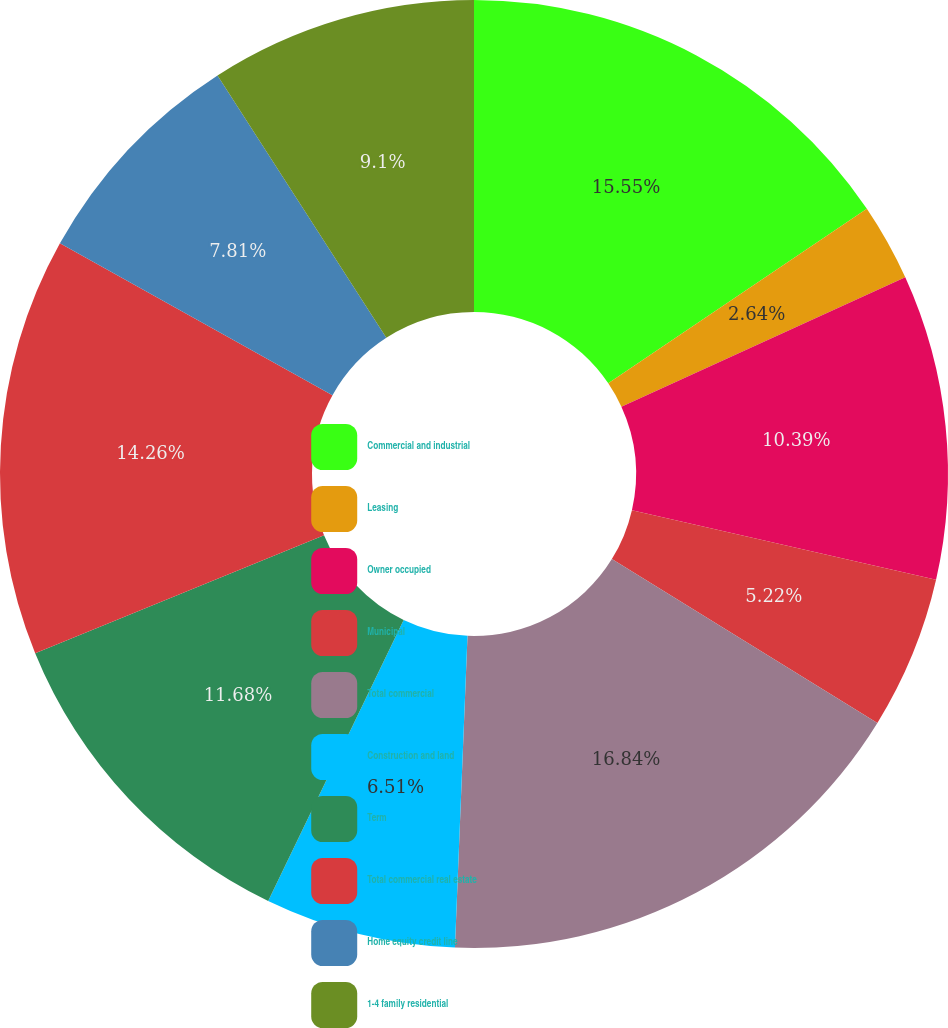<chart> <loc_0><loc_0><loc_500><loc_500><pie_chart><fcel>Commercial and industrial<fcel>Leasing<fcel>Owner occupied<fcel>Municipal<fcel>Total commercial<fcel>Construction and land<fcel>Term<fcel>Total commercial real estate<fcel>Home equity credit line<fcel>1-4 family residential<nl><fcel>15.55%<fcel>2.64%<fcel>10.39%<fcel>5.22%<fcel>16.84%<fcel>6.51%<fcel>11.68%<fcel>14.26%<fcel>7.81%<fcel>9.1%<nl></chart> 